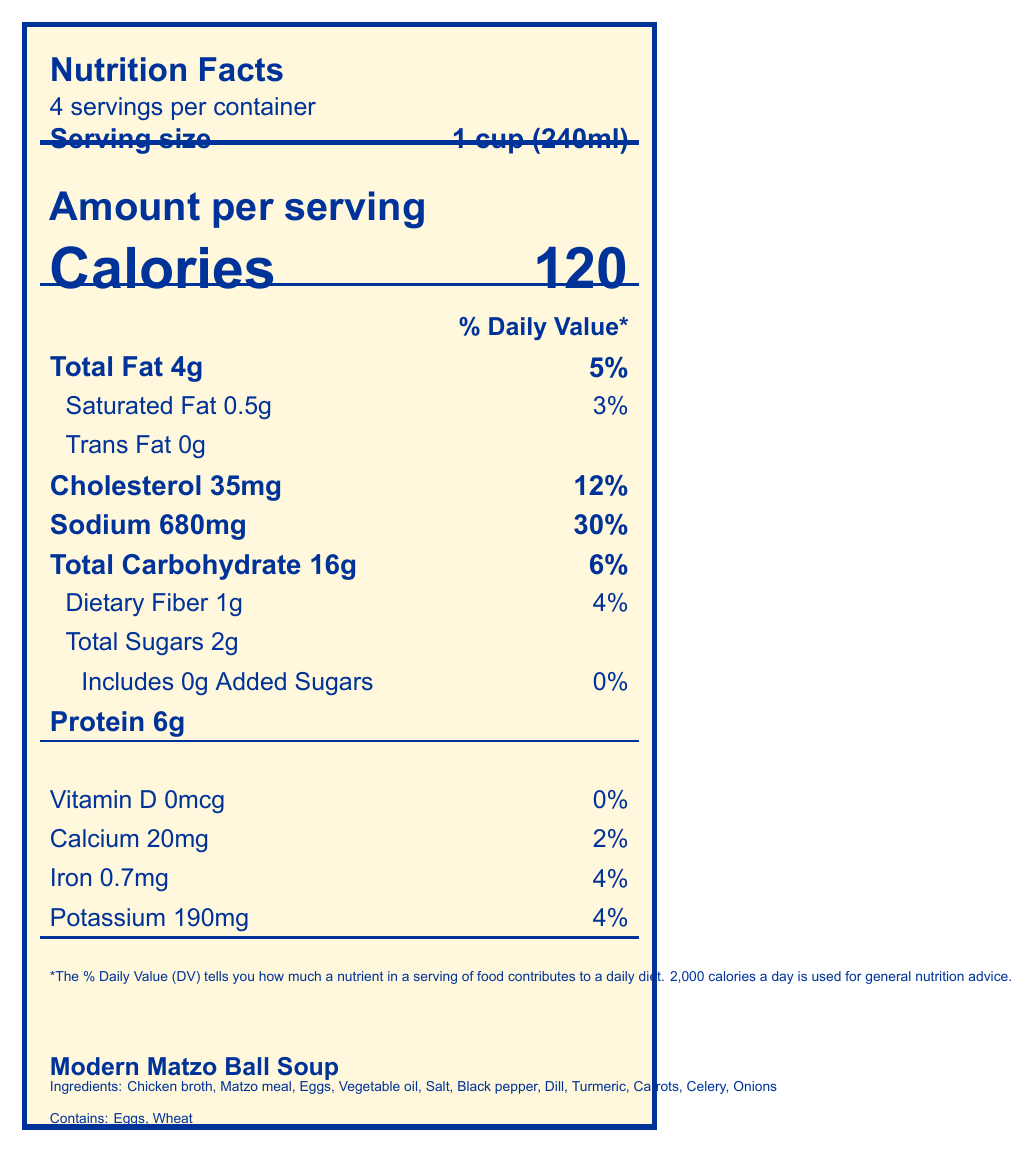what is the serving size? The serving size is listed as "1 cup (240ml)" prominently on the document.
Answer: 1 cup (240ml) how many servings are in the container? The document states that there are 4 servings per container.
Answer: 4 how many calories are in one serving? "Calories" is listed as 120 for one serving.
Answer: 120 what are the main ingredients of the Modern Matzo Ball Soup? The main ingredients are listed at the bottom of the document.
Answer: Chicken broth, Matzo meal, Eggs, Vegetable oil, Salt, Black pepper, Dill, Turmeric, Carrots, Celery, Onions what allergens are present in this food? The allergens are listed as "Contains: Eggs, Wheat" at the bottom of the document.
Answer: Eggs, Wheat what is the daily value percentage of sodium in one serving? The sodium content shows 680mg, which corresponds to 30% of the daily value.
Answer: 30% how much saturated fat is in one serving? The saturated fat content per serving is 0.5g.
Answer: 0.5g how many grams of dietary fiber does one serving contain? The dietary fiber content is listed as 1g per serving.
Answer: 1g which nutrient has the highest daily value percentage? A. Cholesterol B. Sodium C. Total Fat D. Iron Sodium has the highest daily value percentage at 30%, as compared to Cholesterol (12%), Total Fat (5%), and Iron (4%).
Answer: B. Sodium what is the amount of protein in one serving? A. 4g B. 5g C. 6g D. 7g The protein content per serving is listed as 6g.
Answer: C. 6g is this food low in saturated fat? The document mentions it's "Low in saturated fat" in the section "dietary considerations."
Answer: Yes does the food contain any added sugars? The document lists that there are 0g of added sugars.
Answer: No what does the document imply by "modern adaptations"? The "modern adaptations" section describes options for gluten-free and vegan versions.
Answer: Gluten-free version available using almond flour, Vegan option using plant-based egg substitute and vegetable broth what is the cultural significance of this dish? The document notes that this is a traditional Passover dish under "cultural notes."
Answer: Traditional Passover dish describe the entire document in one statement The document provides comprehensive information on the nutritional content, ingredients, and additional adaptations and considerations for Modern Matzo Ball Soup.
Answer: The document is a detailed nutrition facts label for Modern Matzo Ball Soup, highlighting serving size, calories, nutrients, allergens, ingredients, cultural significance, dietary considerations, modern adaptations, and nutritional benefits. how much vitamin D is provided per serving? The vitamin D content per serving is listed as 0mcg.
Answer: 0mcg is this dish considered kosher? The food is marked as "Kosher" under "dietary considerations."
Answer: Yes what is the preparation method mentioned for this soup? The preparation method mentioned is using a slow-cooker.
Answer: Prepared using a slow-cooker for convenience what are the serving suggestions provided? The serving suggestions mention pairing with whole grain crackers and serving with a side salad.
Answer: Pair with whole grain crackers for added fiber, Serve with a side salad for a balanced meal what is the total carbohydrate content in one serving, and what percentage of the daily value does it represent? The total carbohydrate content per serving is 16g, which represents 6% of the daily value.
Answer: 16g, 6% what specific health benefits are highlighted due to the addition of turmeric? The addition of turmeric is noted to provide antioxidants from turmeric and vegetables.
Answer: Contains antioxidants from turmeric and vegetables is this product dairy-free? The document mentions that the soup is "Dairy-free" under "dietary considerations."
Answer: Yes how is the texture and taste of the matzo ball soup described? The document does not provide any description regarding the texture and taste of the matzo ball soup.
Answer: Not enough information 